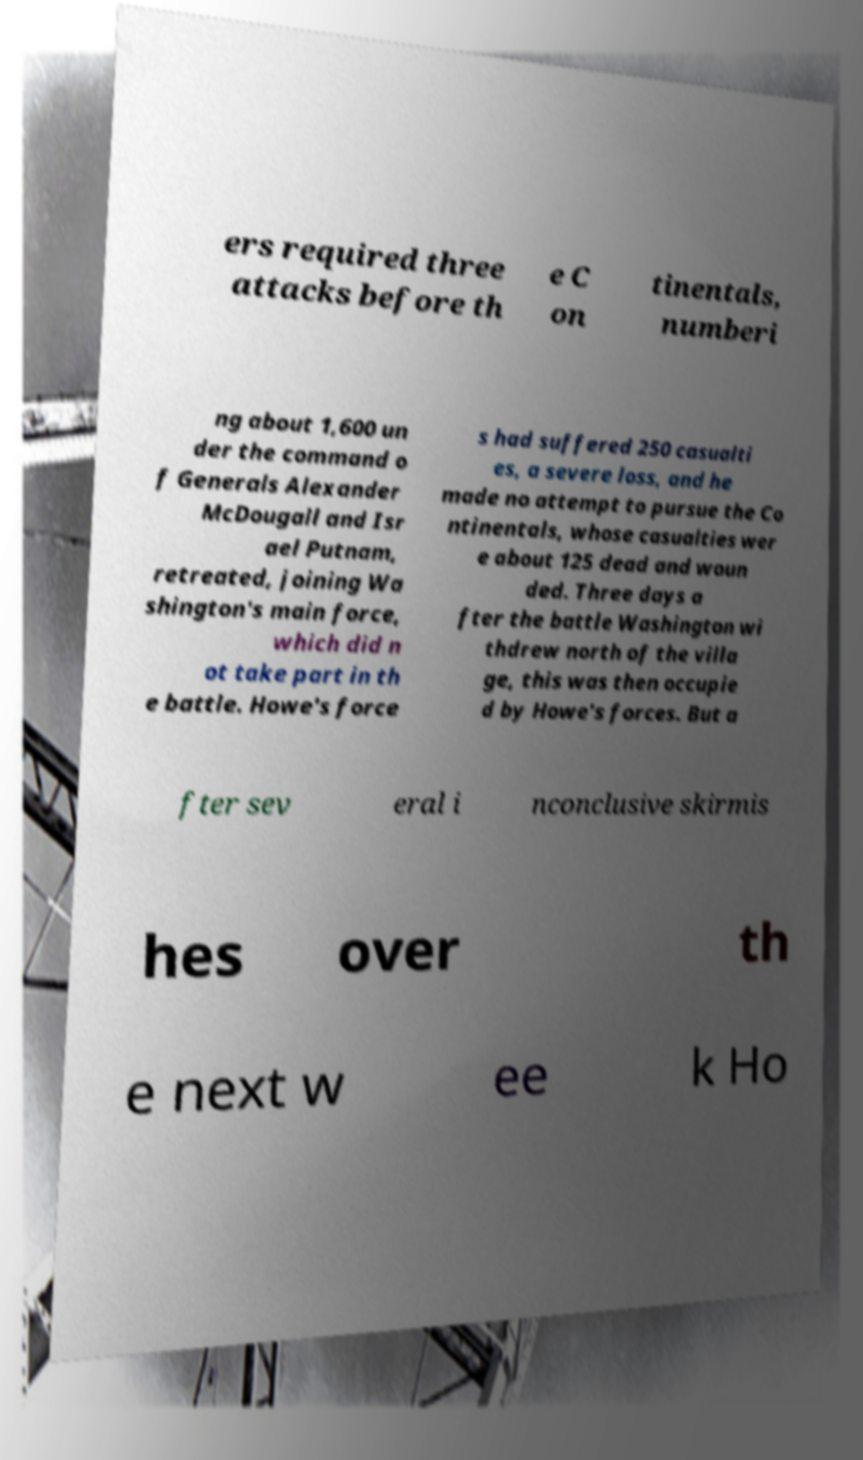For documentation purposes, I need the text within this image transcribed. Could you provide that? ers required three attacks before th e C on tinentals, numberi ng about 1,600 un der the command o f Generals Alexander McDougall and Isr ael Putnam, retreated, joining Wa shington's main force, which did n ot take part in th e battle. Howe's force s had suffered 250 casualti es, a severe loss, and he made no attempt to pursue the Co ntinentals, whose casualties wer e about 125 dead and woun ded. Three days a fter the battle Washington wi thdrew north of the villa ge, this was then occupie d by Howe's forces. But a fter sev eral i nconclusive skirmis hes over th e next w ee k Ho 